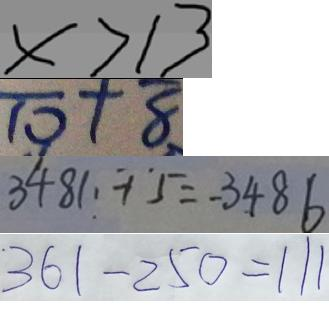Convert formula to latex. <formula><loc_0><loc_0><loc_500><loc_500>x > 1 3 
 \overline { 1 0 } + \overline { 8 } 
 3 4 8 1 + 5 = 3 4 8 6 
 3 6 1 - 2 5 0 = 1 1 1</formula> 